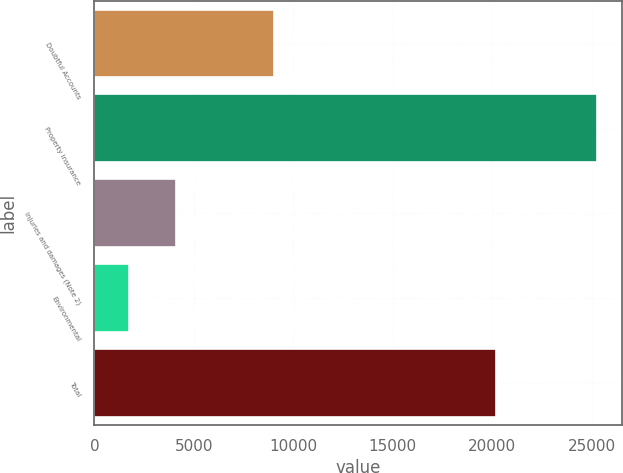Convert chart. <chart><loc_0><loc_0><loc_500><loc_500><bar_chart><fcel>Doubtful Accounts<fcel>Property insurance<fcel>Injuries and damages (Note 2)<fcel>Environmental<fcel>Total<nl><fcel>9020<fcel>25283<fcel>4084.4<fcel>1729<fcel>20201<nl></chart> 